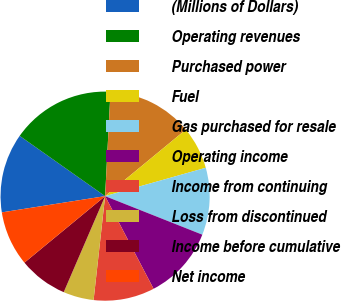Convert chart. <chart><loc_0><loc_0><loc_500><loc_500><pie_chart><fcel>(Millions of Dollars)<fcel>Operating revenues<fcel>Purchased power<fcel>Fuel<fcel>Gas purchased for resale<fcel>Operating income<fcel>Income from continuing<fcel>Loss from discontinued<fcel>Income before cumulative<fcel>Net income<nl><fcel>12.26%<fcel>16.04%<fcel>13.21%<fcel>6.6%<fcel>10.38%<fcel>11.32%<fcel>9.43%<fcel>4.72%<fcel>7.55%<fcel>8.49%<nl></chart> 